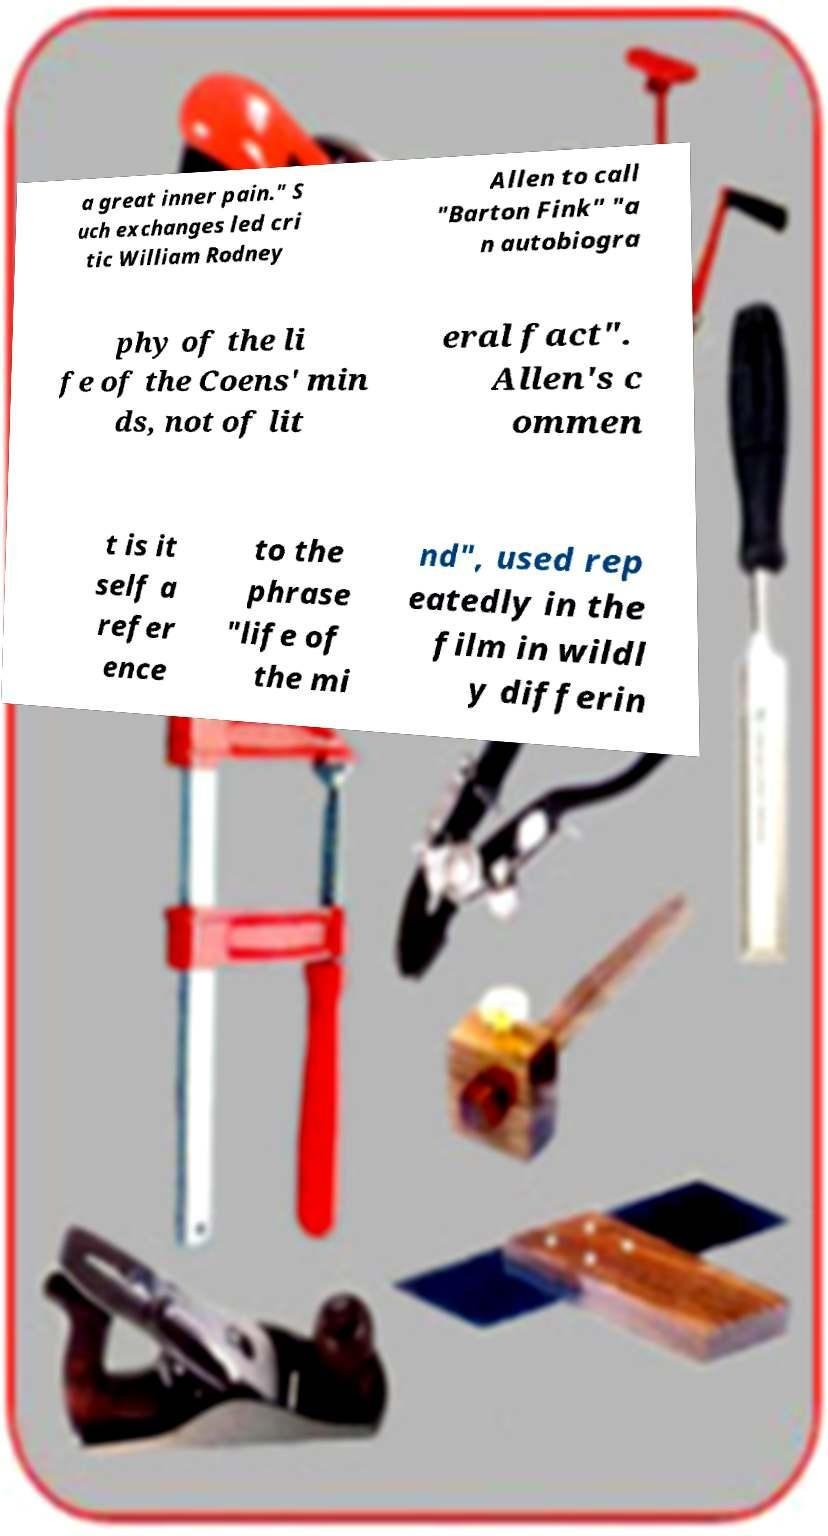Please identify and transcribe the text found in this image. a great inner pain." S uch exchanges led cri tic William Rodney Allen to call "Barton Fink" "a n autobiogra phy of the li fe of the Coens' min ds, not of lit eral fact". Allen's c ommen t is it self a refer ence to the phrase "life of the mi nd", used rep eatedly in the film in wildl y differin 